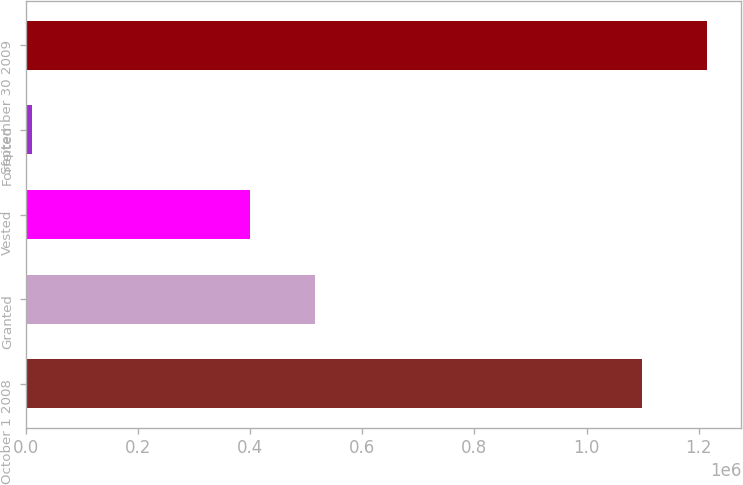<chart> <loc_0><loc_0><loc_500><loc_500><bar_chart><fcel>October 1 2008<fcel>Granted<fcel>Vested<fcel>Forfeited<fcel>September 30 2009<nl><fcel>1.09936e+06<fcel>515785<fcel>400332<fcel>10928<fcel>1.21482e+06<nl></chart> 